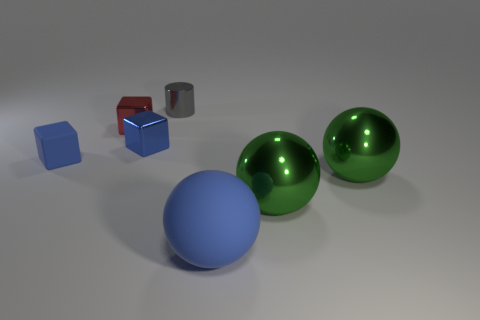There is a metal object that is the same color as the big matte sphere; what is its shape?
Make the answer very short. Cube. What is the size of the shiny cube that is the same color as the matte block?
Provide a succinct answer. Small. Does the red metallic cube have the same size as the rubber sphere?
Your response must be concise. No. What number of cubes are either shiny things or big matte objects?
Offer a very short reply. 2. How many metallic things are on the right side of the blue object that is behind the blue matte cube?
Give a very brief answer. 3. Do the big rubber thing and the gray shiny object have the same shape?
Provide a short and direct response. No. What is the size of the red object that is the same shape as the tiny blue rubber thing?
Your answer should be compact. Small. What shape is the tiny blue thing that is behind the rubber thing that is to the left of the small metallic cylinder?
Keep it short and to the point. Cube. What is the size of the red metallic object?
Your answer should be compact. Small. What shape is the tiny blue matte thing?
Keep it short and to the point. Cube. 